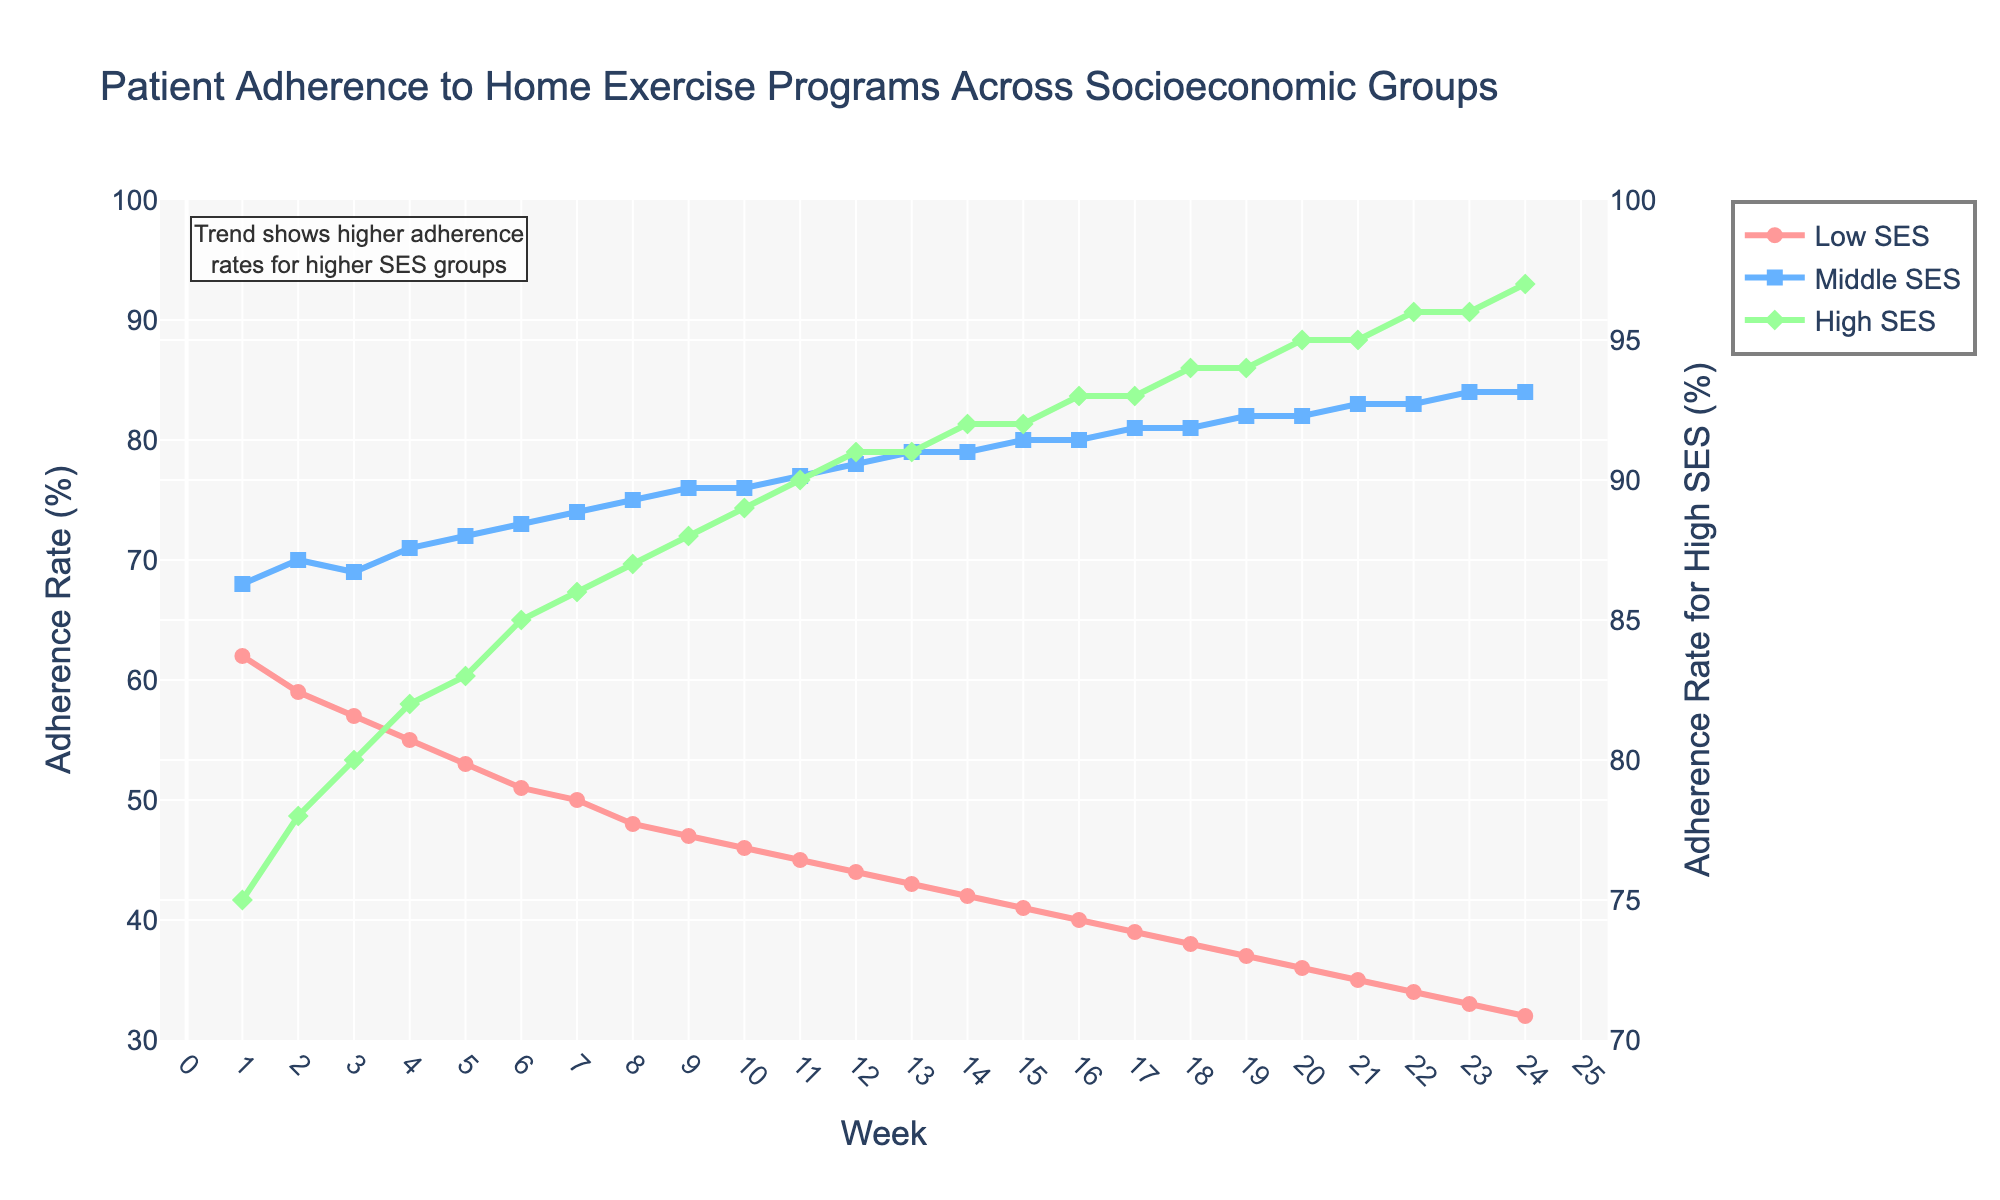Which socioeconomic group shows the highest adherence rate overall? By inspecting each line, the green line representing the High SES group is always at the top, consistently showing higher adherence rates compared to the other groups.
Answer: High SES How does the adherence rate of the Low SES group change over the 24 weeks? The adherence rate of the Low SES group shows a decreasing trend over the weeks, starting from 62% in week 1 and dropping to 32% by week 24.
Answer: Decreases from 62% to 32% Compare the adherence rates of the Middle SES and High SES groups at week 10. At week 10, the adherence rate for the Middle SES group (blue line) is 76%, while the High SES group (green line) has an adherence rate of 89%.
Answer: Middle SES: 76%, High SES: 89% Which group shows the most significant decline in adherence over the 24 weeks? The Low SES group shows the most significant decline, dropping from 62% in week 1 to 32% in week 24, a decrease of 30 percentage points.
Answer: Low SES At which week do the Middle SES and High SES groups have the same adherence rate? The Middle SES (blue line) and High SES (green line) groups have the same adherence rate of 81% in week 17 and week 18.
Answer: Weeks 17 and 18 What is the range of adherence rates for the High SES group over the 24 weeks? The adherence rates for the High SES group range from 75% at week 1 to 97% at week 24.
Answer: 75%-97% On which week does the Low SES group's adherence rate fall below 50% for the first time? The Low SES group's adherence rate falls below 50% for the first time at week 8, where the rate is 48%.
Answer: Week 8 What is the difference in adherence rate between the Low SES and High SES groups in week 5? At week 5, the Low SES group has an adherence rate of 53%, and the High SES group has a rate of 83%. The difference is 83% - 53% = 30%.
Answer: 30% Which group has a relatively steady adherence rate over the 24 weeks? The Middle SES group (blue line) shows a relatively steady adherence rate with only small fluctuations over the 24 weeks, ranging from 68% to 84%.
Answer: Middle SES Does any group's adherence rate remain above 90% at any week? The High SES group's adherence rate remains above 90% from week 12 onwards, peaking at 97% by week 24.
Answer: High SES 